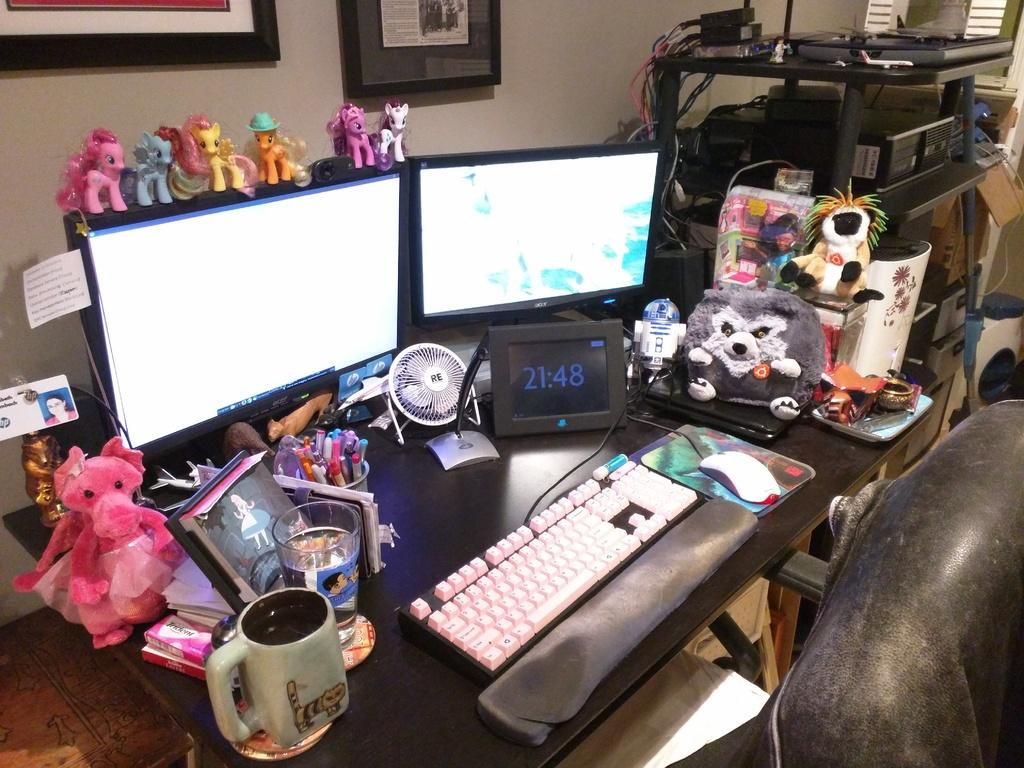What objects are on the table in the image? There is a cup, a glass, a toy, monitors, a keyboard, and a mouse on the table. What else can be seen on the table? There are also unspecified "things" on the table. What is visible on the wall in the image? There are pictures on the wall. What type of race is happening in the image? There are laptops and devices in a race. What type of tin can be seen being used as a drumstick in the image? There is no tin or drumstick present in the image. What type of sticks are being used to play with the toy in the image? There are no sticks present in the image; the toy is not being played with. What type of spoon is being used to stir the contents of the cup in the image? There is no spoon present in the image; the cup is not being stirred. 